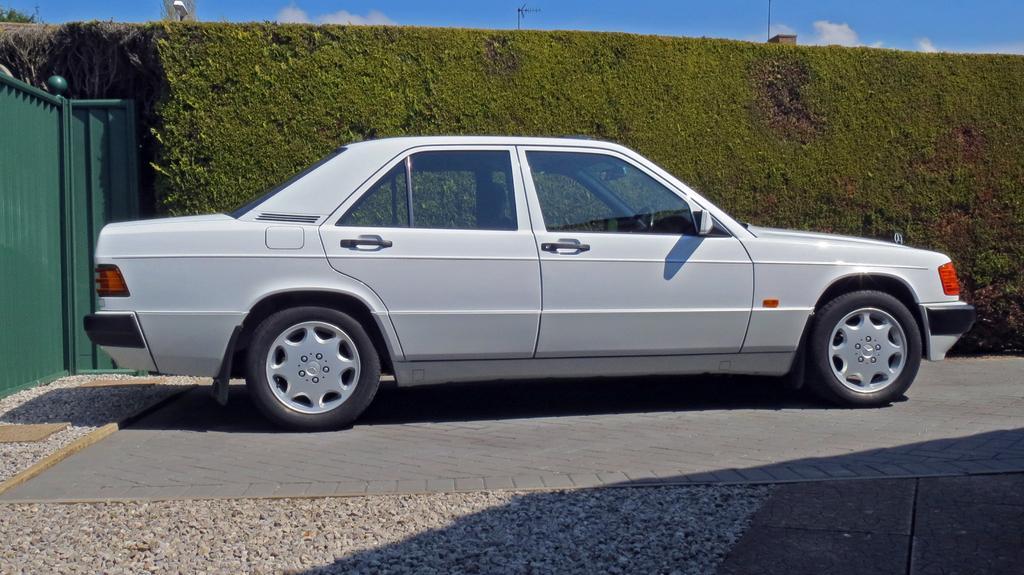Describe this image in one or two sentences. In the picture I can see a car which is in white color and there is a green fence in the left corner and there is greenery beside the car and there are some other objects in the background. 